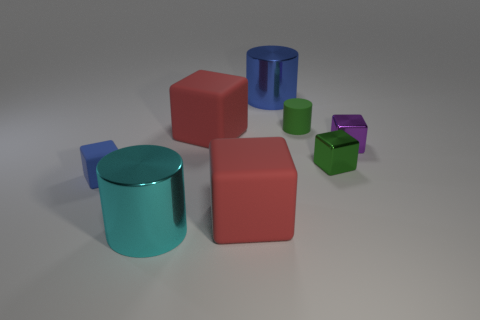What material is the small object on the left side of the green rubber thing?
Your answer should be very brief. Rubber. What is the size of the cube that is the same color as the matte cylinder?
Keep it short and to the point. Small. Is the number of blue metallic cylinders that are in front of the purple metal cube less than the number of large cylinders that are on the right side of the tiny rubber block?
Your answer should be compact. Yes. What shape is the big metallic object that is in front of the blue thing that is behind the small rubber thing left of the large blue cylinder?
Your answer should be compact. Cylinder. There is a small matte object on the left side of the big blue metallic thing; is it the same color as the big object behind the green cylinder?
Offer a terse response. Yes. What shape is the large object that is the same color as the small matte cube?
Your answer should be compact. Cylinder. How many matte things are either blue cylinders or big cylinders?
Make the answer very short. 0. What is the color of the large metallic cylinder right of the big red object that is in front of the small matte thing in front of the green rubber cylinder?
Provide a succinct answer. Blue. The other shiny thing that is the same shape as the small purple thing is what color?
Make the answer very short. Green. Are there any other things that have the same color as the small cylinder?
Provide a succinct answer. Yes. 